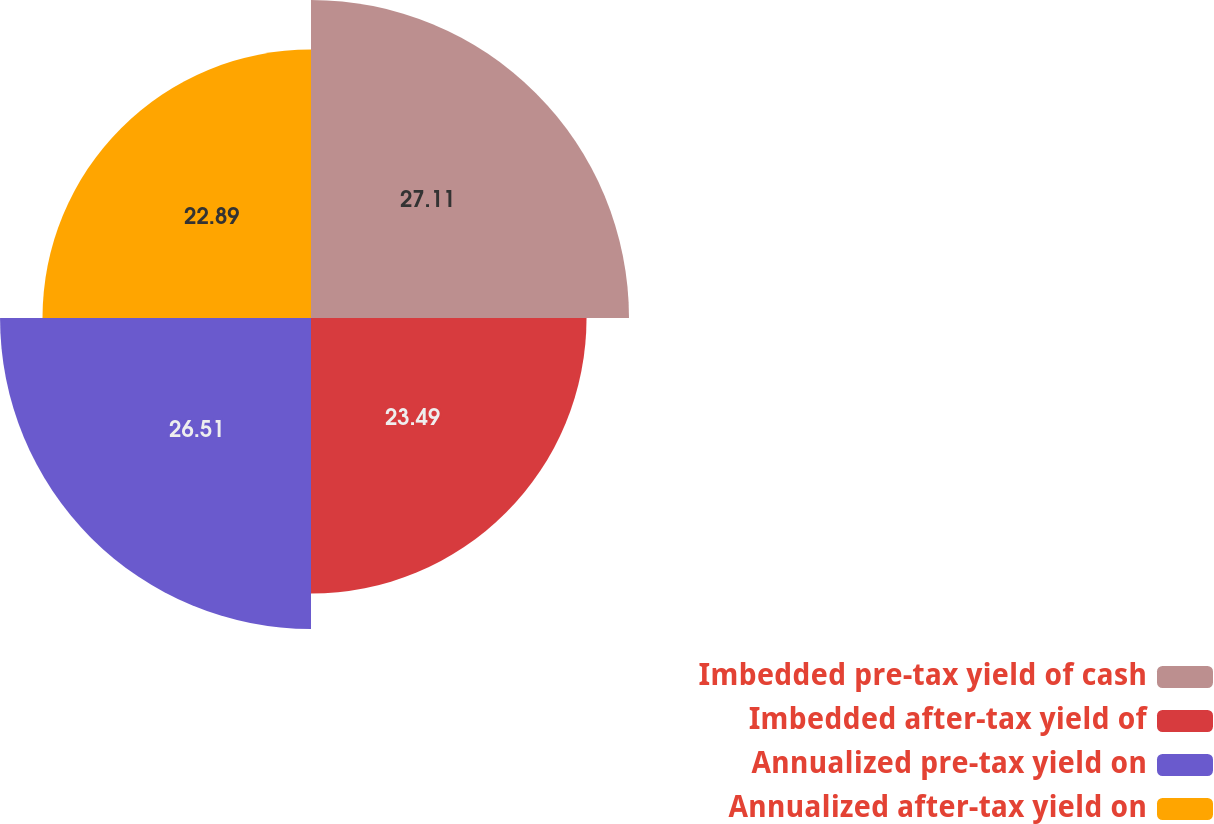<chart> <loc_0><loc_0><loc_500><loc_500><pie_chart><fcel>Imbedded pre-tax yield of cash<fcel>Imbedded after-tax yield of<fcel>Annualized pre-tax yield on<fcel>Annualized after-tax yield on<nl><fcel>27.11%<fcel>23.49%<fcel>26.51%<fcel>22.89%<nl></chart> 